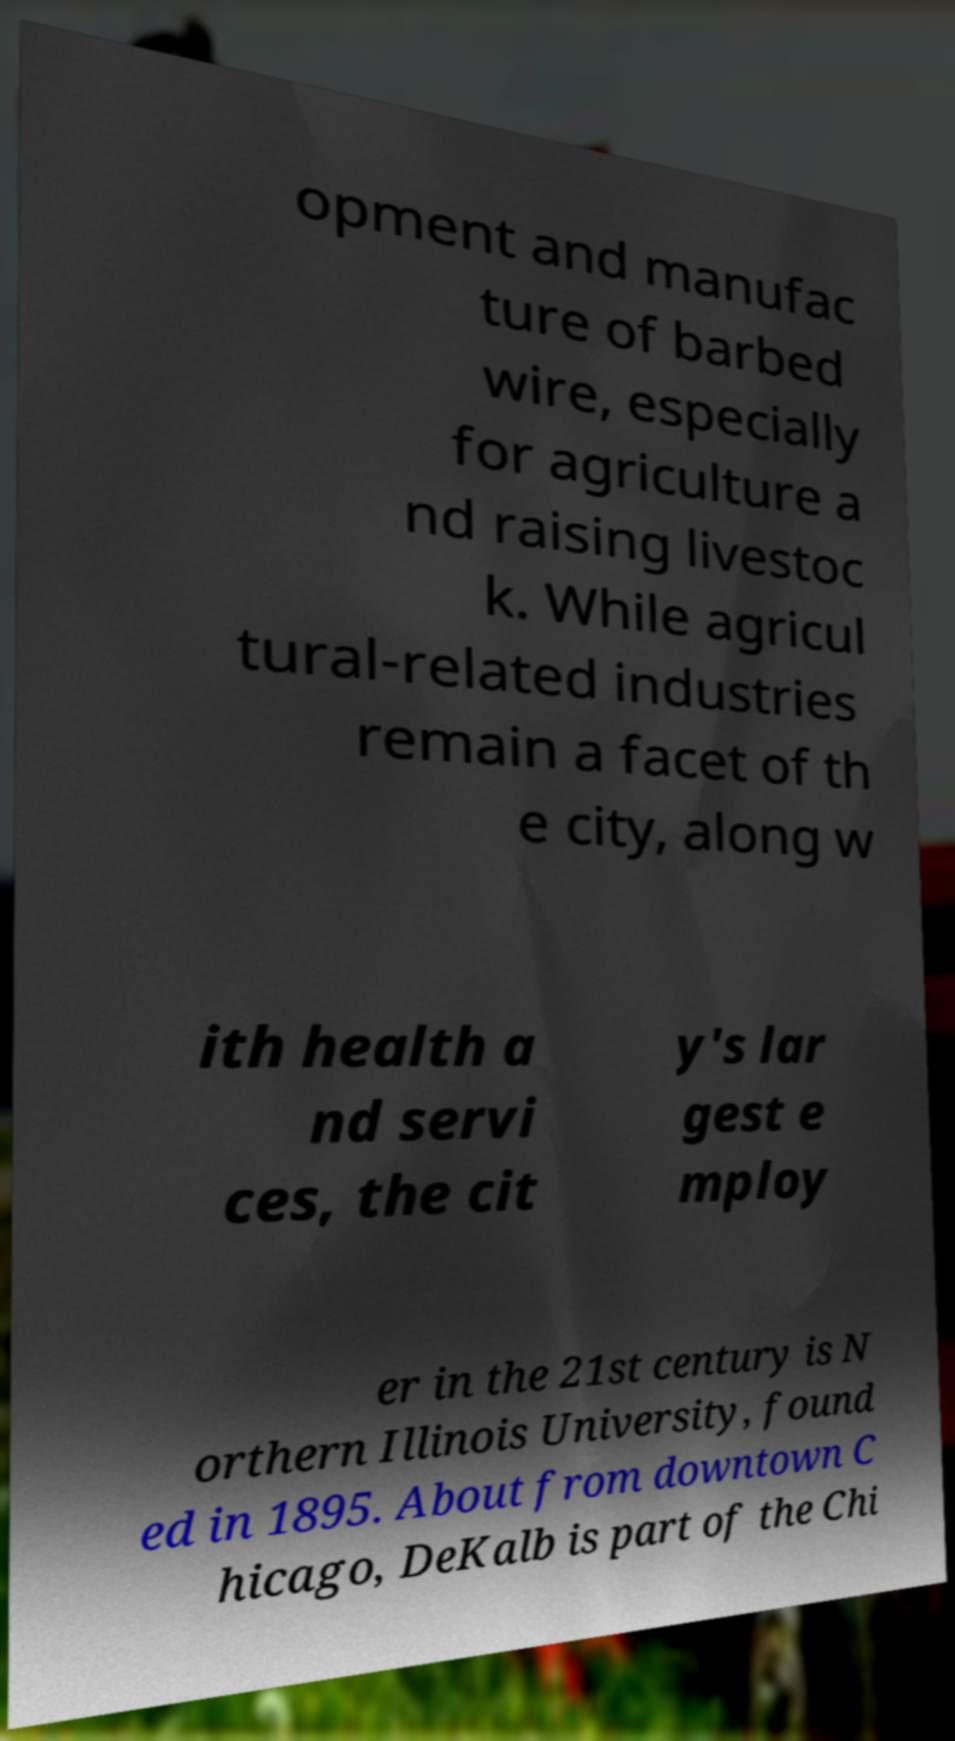I need the written content from this picture converted into text. Can you do that? opment and manufac ture of barbed wire, especially for agriculture a nd raising livestoc k. While agricul tural-related industries remain a facet of th e city, along w ith health a nd servi ces, the cit y's lar gest e mploy er in the 21st century is N orthern Illinois University, found ed in 1895. About from downtown C hicago, DeKalb is part of the Chi 